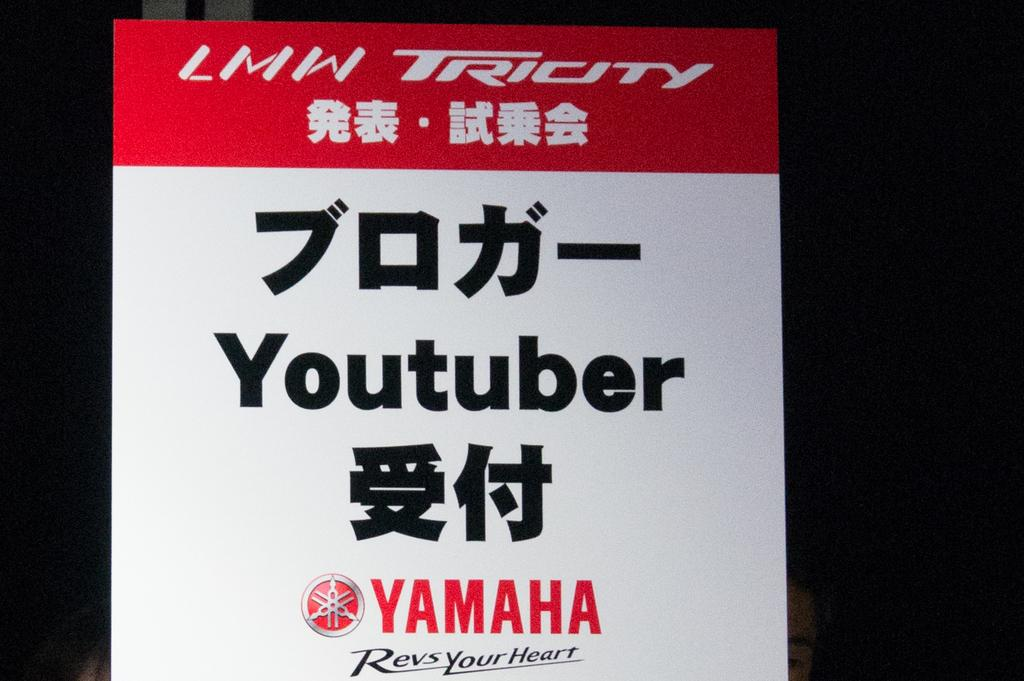<image>
Describe the image concisely. A red and white Yamaha advertisement with the Yamaha logo and a mix of words in English and a foreign language. 